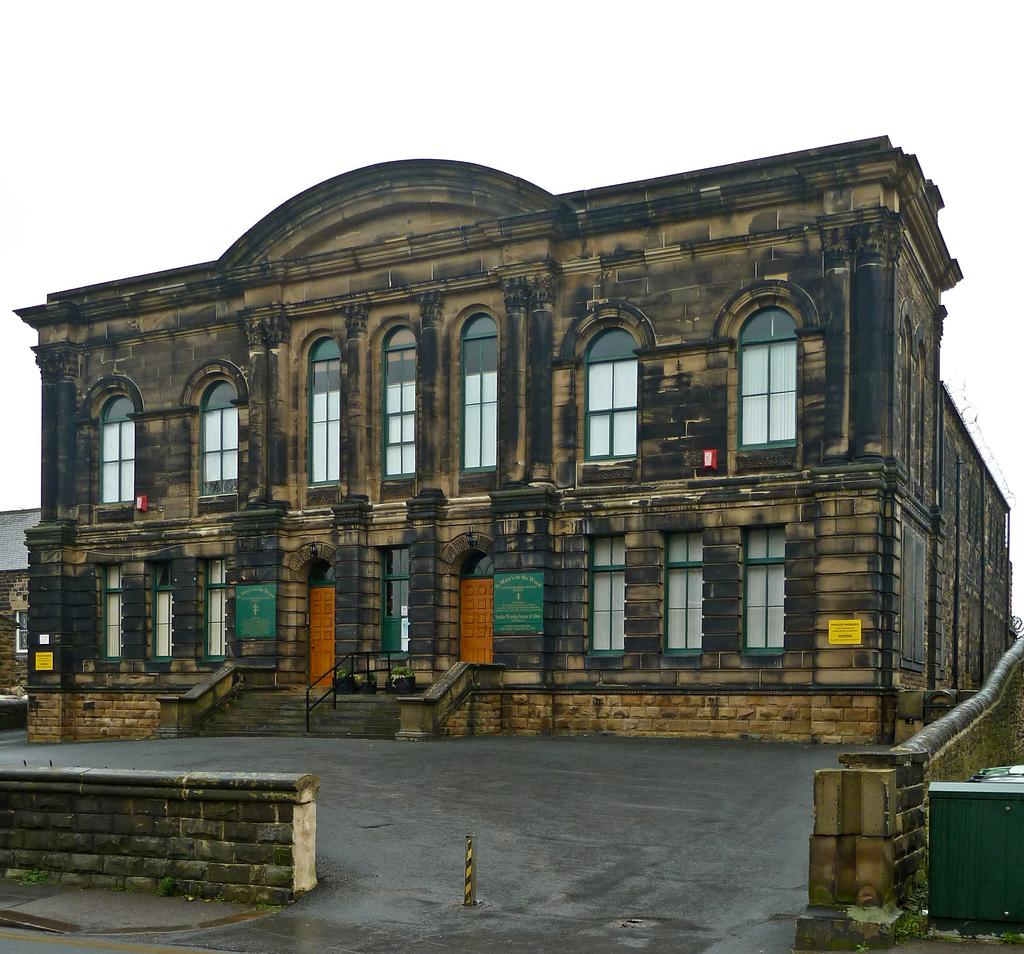What is the main structure in the image? There is a building in the image. What can be seen in the background of the image? The sky is visible in the background of the image. What type of substance is being carried by the dad in the image? There is no dad or substance present in the image; it only features a building and the sky. 